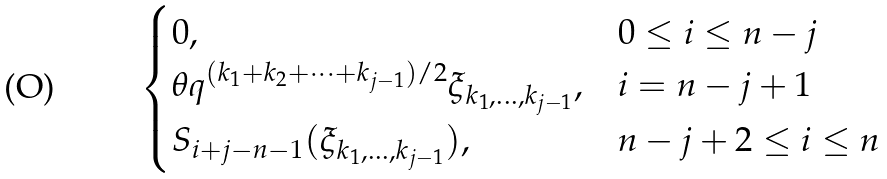Convert formula to latex. <formula><loc_0><loc_0><loc_500><loc_500>\begin{cases} 0 , & 0 \leq i \leq n - j \\ \theta q ^ { ( k _ { 1 } + k _ { 2 } + \cdots + k _ { j - 1 } ) / 2 } \xi _ { k _ { 1 } , \dots , k _ { j - 1 } } , & i = n - j + 1 \\ S _ { i + j - n - 1 } ( \xi _ { k _ { 1 } , \dots , k _ { j - 1 } } ) , & n - j + 2 \leq i \leq n \end{cases}</formula> 